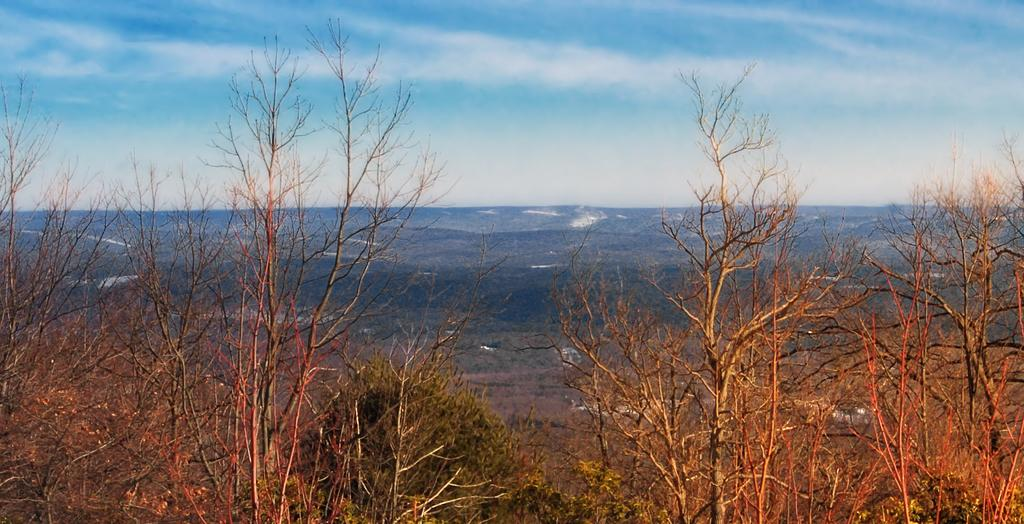What type of vegetation can be seen in the image? There are trees in the image. What geographical features are present in the image? There are hills in the image. What is visible in the background of the image? The sky is visible in the background of the image. What type of polish is being applied to the street in the image? There is no street or polish present in the image; it features trees and hills with a visible sky in the background. Can you describe the ray of light shining on the trees in the image? There is no specific ray of light mentioned or depicted in the image; it simply shows trees, hills, and the sky. 